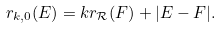Convert formula to latex. <formula><loc_0><loc_0><loc_500><loc_500>r _ { k , 0 } ( E ) = k r _ { \mathcal { R } } ( F ) + | E - F | .</formula> 